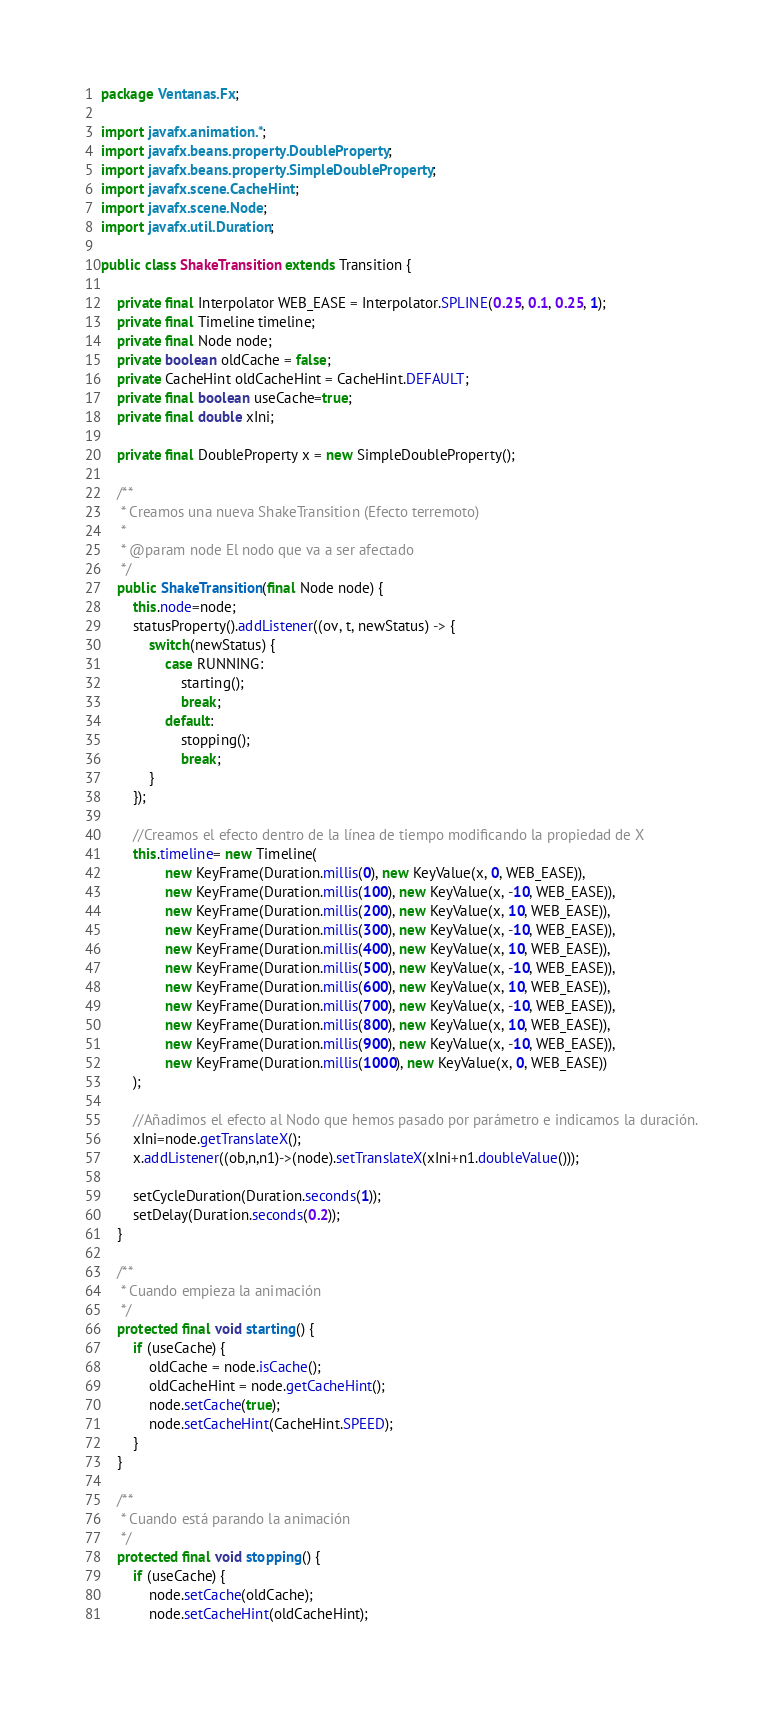Convert code to text. <code><loc_0><loc_0><loc_500><loc_500><_Java_>package Ventanas.Fx;

import javafx.animation.*;
import javafx.beans.property.DoubleProperty;
import javafx.beans.property.SimpleDoubleProperty;
import javafx.scene.CacheHint;
import javafx.scene.Node;
import javafx.util.Duration;

public class ShakeTransition extends Transition {

	private final Interpolator WEB_EASE = Interpolator.SPLINE(0.25, 0.1, 0.25, 1);
	private final Timeline timeline;
	private final Node node;
	private boolean oldCache = false;
	private CacheHint oldCacheHint = CacheHint.DEFAULT;
	private final boolean useCache=true;
	private final double xIni;

	private final DoubleProperty x = new SimpleDoubleProperty();

	/**
	 * Creamos una nueva ShakeTransition (Efecto terremoto)
	 *
	 * @param node El nodo que va a ser afectado
	 */
	public ShakeTransition(final Node node) {
		this.node=node;
		statusProperty().addListener((ov, t, newStatus) -> {
			switch(newStatus) {
				case RUNNING:
					starting();
					break;
				default:
					stopping();
					break;
			}
		});

		//Creamos el efecto dentro de la línea de tiempo modificando la propiedad de X
		this.timeline= new Timeline(
				new KeyFrame(Duration.millis(0), new KeyValue(x, 0, WEB_EASE)),
				new KeyFrame(Duration.millis(100), new KeyValue(x, -10, WEB_EASE)),
				new KeyFrame(Duration.millis(200), new KeyValue(x, 10, WEB_EASE)),
				new KeyFrame(Duration.millis(300), new KeyValue(x, -10, WEB_EASE)),
				new KeyFrame(Duration.millis(400), new KeyValue(x, 10, WEB_EASE)),
				new KeyFrame(Duration.millis(500), new KeyValue(x, -10, WEB_EASE)),
				new KeyFrame(Duration.millis(600), new KeyValue(x, 10, WEB_EASE)),
				new KeyFrame(Duration.millis(700), new KeyValue(x, -10, WEB_EASE)),
				new KeyFrame(Duration.millis(800), new KeyValue(x, 10, WEB_EASE)),
				new KeyFrame(Duration.millis(900), new KeyValue(x, -10, WEB_EASE)),
				new KeyFrame(Duration.millis(1000), new KeyValue(x, 0, WEB_EASE))
		);

		//Añadimos el efecto al Nodo que hemos pasado por parámetro e indicamos la duración.
		xIni=node.getTranslateX();
		x.addListener((ob,n,n1)->(node).setTranslateX(xIni+n1.doubleValue()));

		setCycleDuration(Duration.seconds(1));
		setDelay(Duration.seconds(0.2));
	}

	/**
	 * Cuando empieza la animación
	 */
	protected final void starting() {
		if (useCache) {
			oldCache = node.isCache();
			oldCacheHint = node.getCacheHint();
			node.setCache(true);
			node.setCacheHint(CacheHint.SPEED);
		}
	}

	/**
	 * Cuando está parando la animación
	 */
	protected final void stopping() {
		if (useCache) {
			node.setCache(oldCache);
			node.setCacheHint(oldCacheHint);</code> 